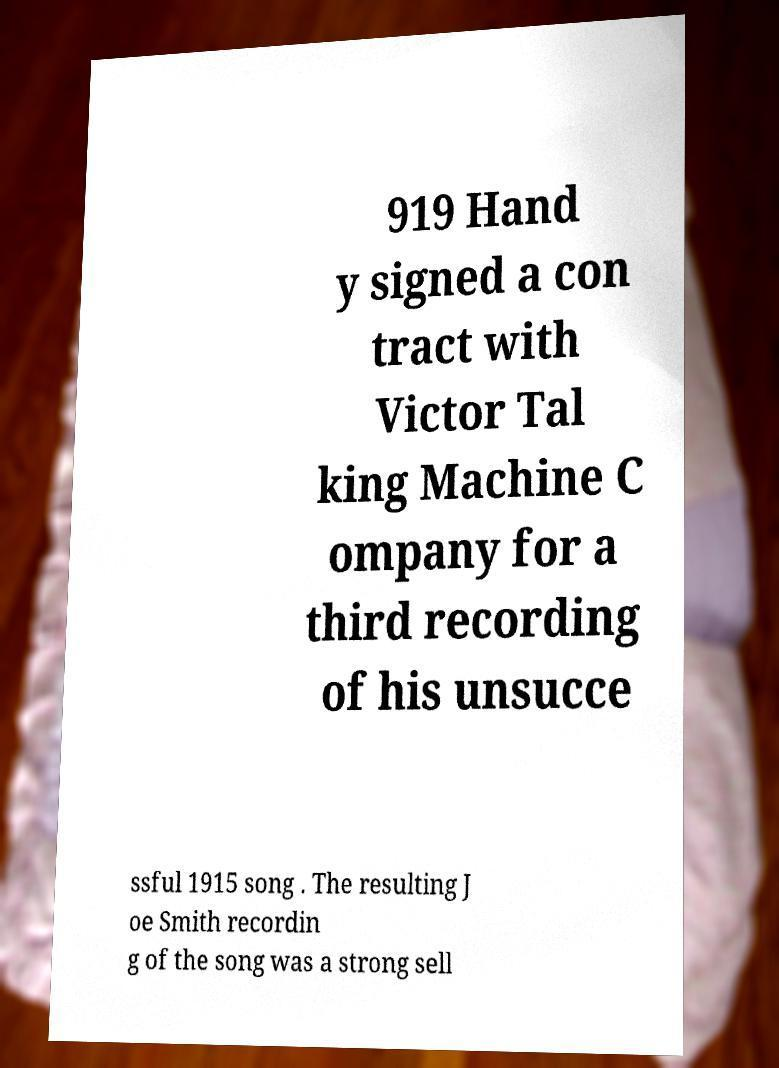Please identify and transcribe the text found in this image. 919 Hand y signed a con tract with Victor Tal king Machine C ompany for a third recording of his unsucce ssful 1915 song . The resulting J oe Smith recordin g of the song was a strong sell 